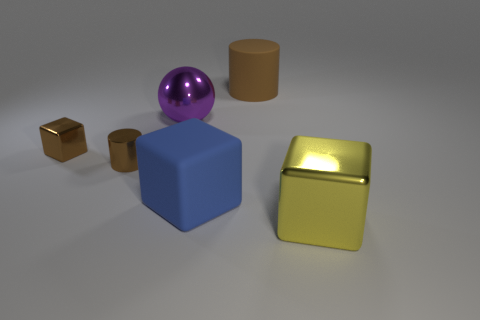Subtract all large rubber blocks. How many blocks are left? 2 Add 2 purple matte things. How many objects exist? 8 Subtract all yellow cubes. How many cubes are left? 2 Subtract 2 cylinders. How many cylinders are left? 0 Subtract all brown balls. Subtract all purple cylinders. How many balls are left? 1 Subtract all metal balls. Subtract all big things. How many objects are left? 1 Add 6 brown metal objects. How many brown metal objects are left? 8 Add 5 spheres. How many spheres exist? 6 Subtract 0 cyan cylinders. How many objects are left? 6 Subtract all spheres. How many objects are left? 5 